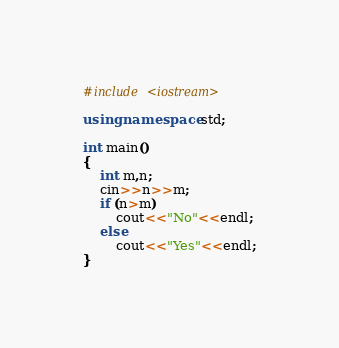<code> <loc_0><loc_0><loc_500><loc_500><_C++_>#include <iostream>

using namespace std;

int main()
{
    int m,n;
    cin>>n>>m;
    if (n>m)
        cout<<"No"<<endl;
    else
        cout<<"Yes"<<endl;
}
</code> 